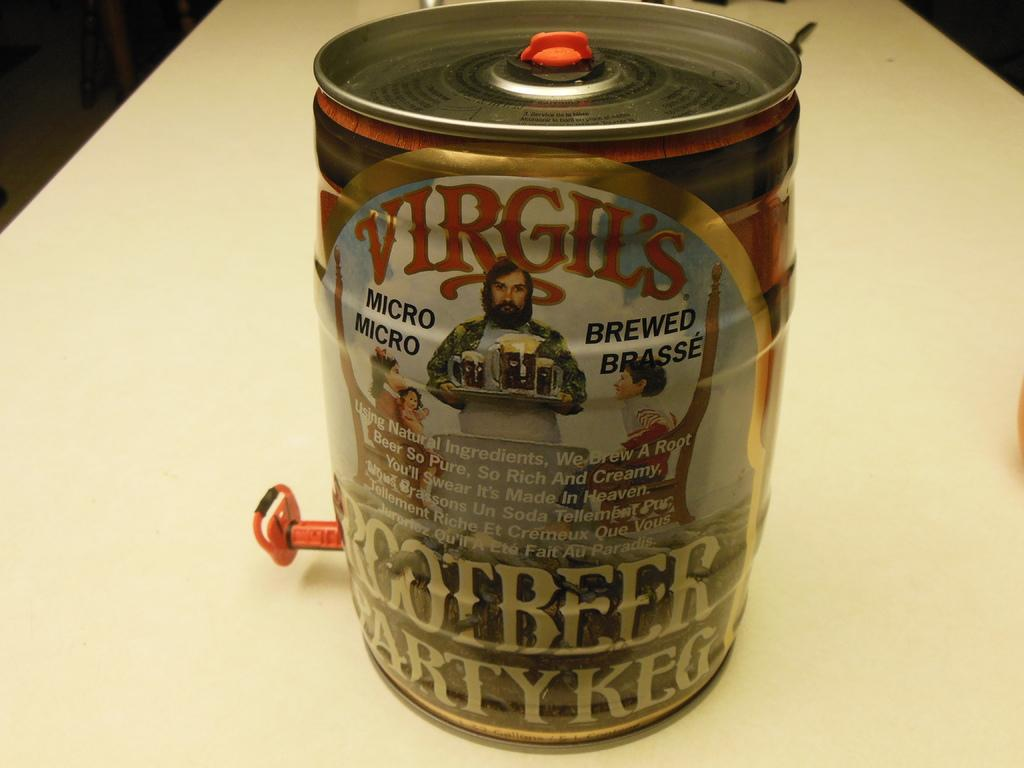<image>
Give a short and clear explanation of the subsequent image. A keg of Virgil's micro brew root beer. 